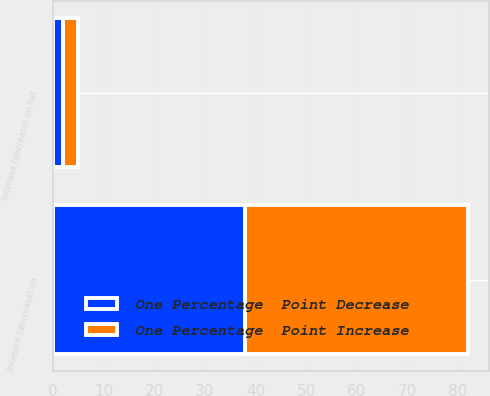Convert chart. <chart><loc_0><loc_0><loc_500><loc_500><stacked_bar_chart><ecel><fcel>Increase (decrease) on<fcel>Increase (decrease) on net<nl><fcel>One Percentage  Point Decrease<fcel>38<fcel>2<nl><fcel>One Percentage  Point Increase<fcel>44<fcel>3<nl></chart> 